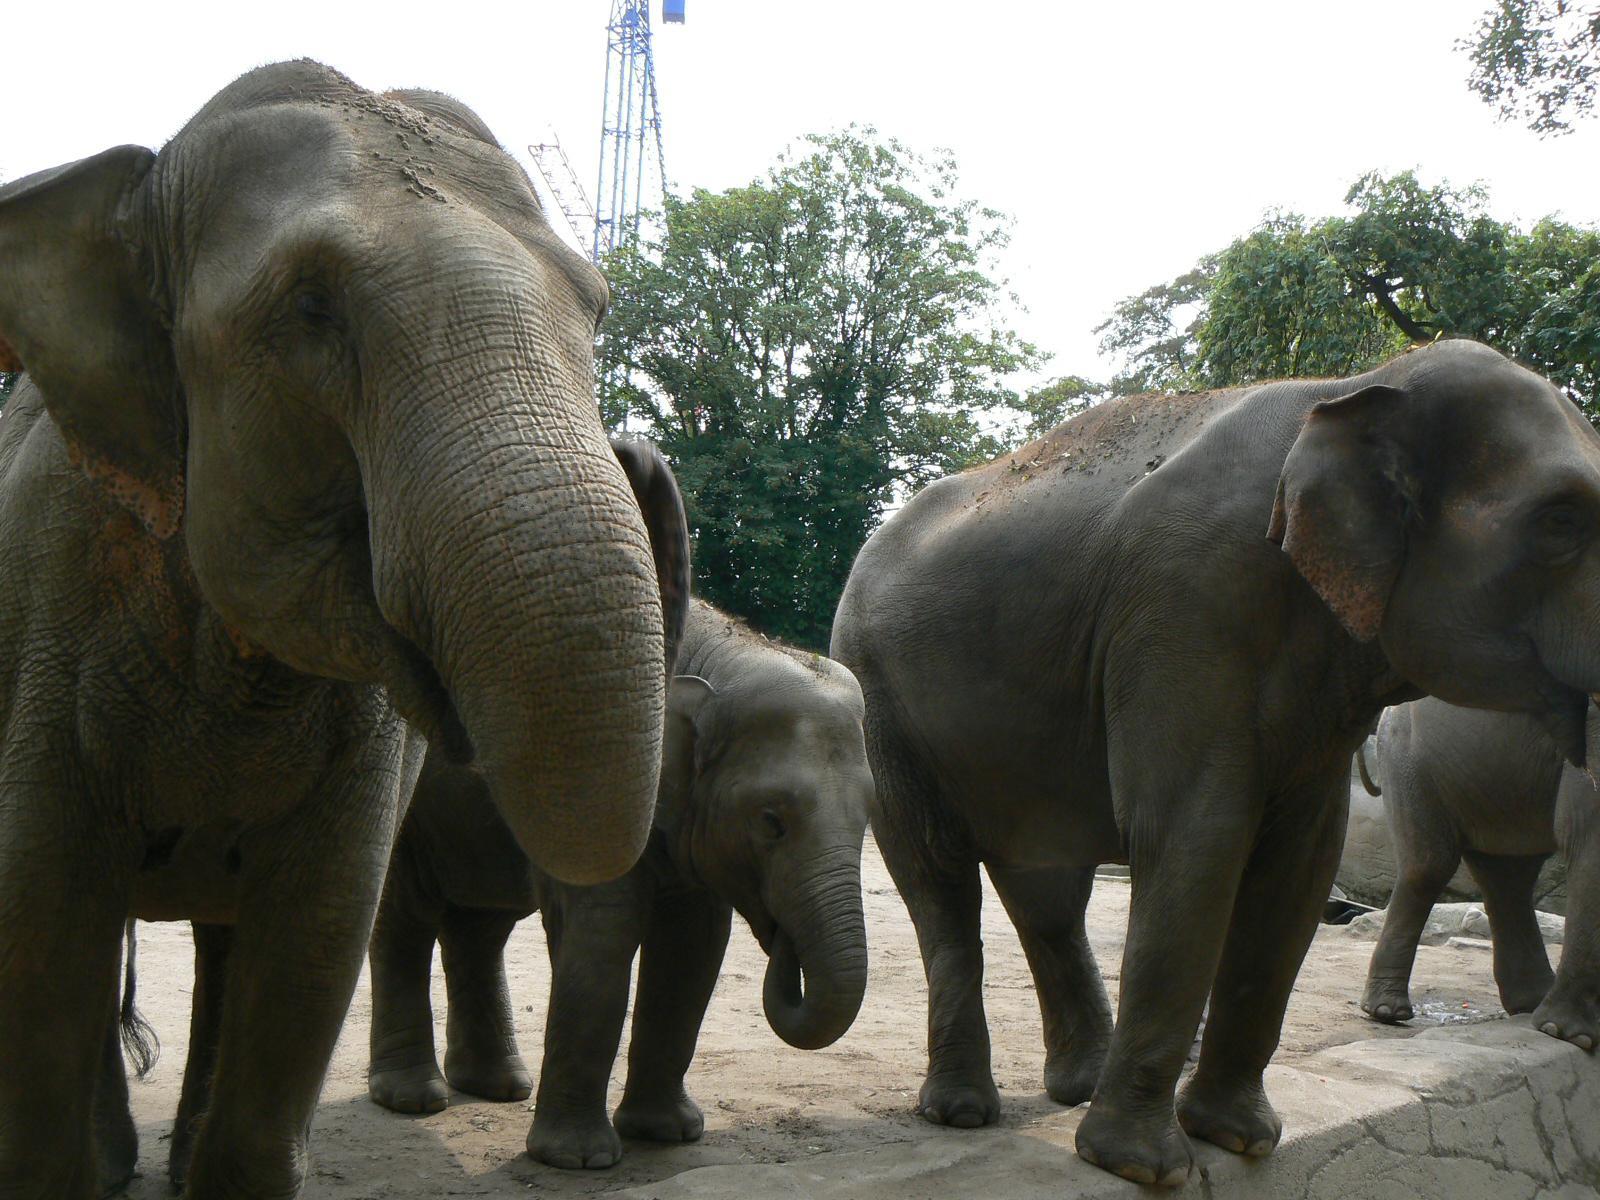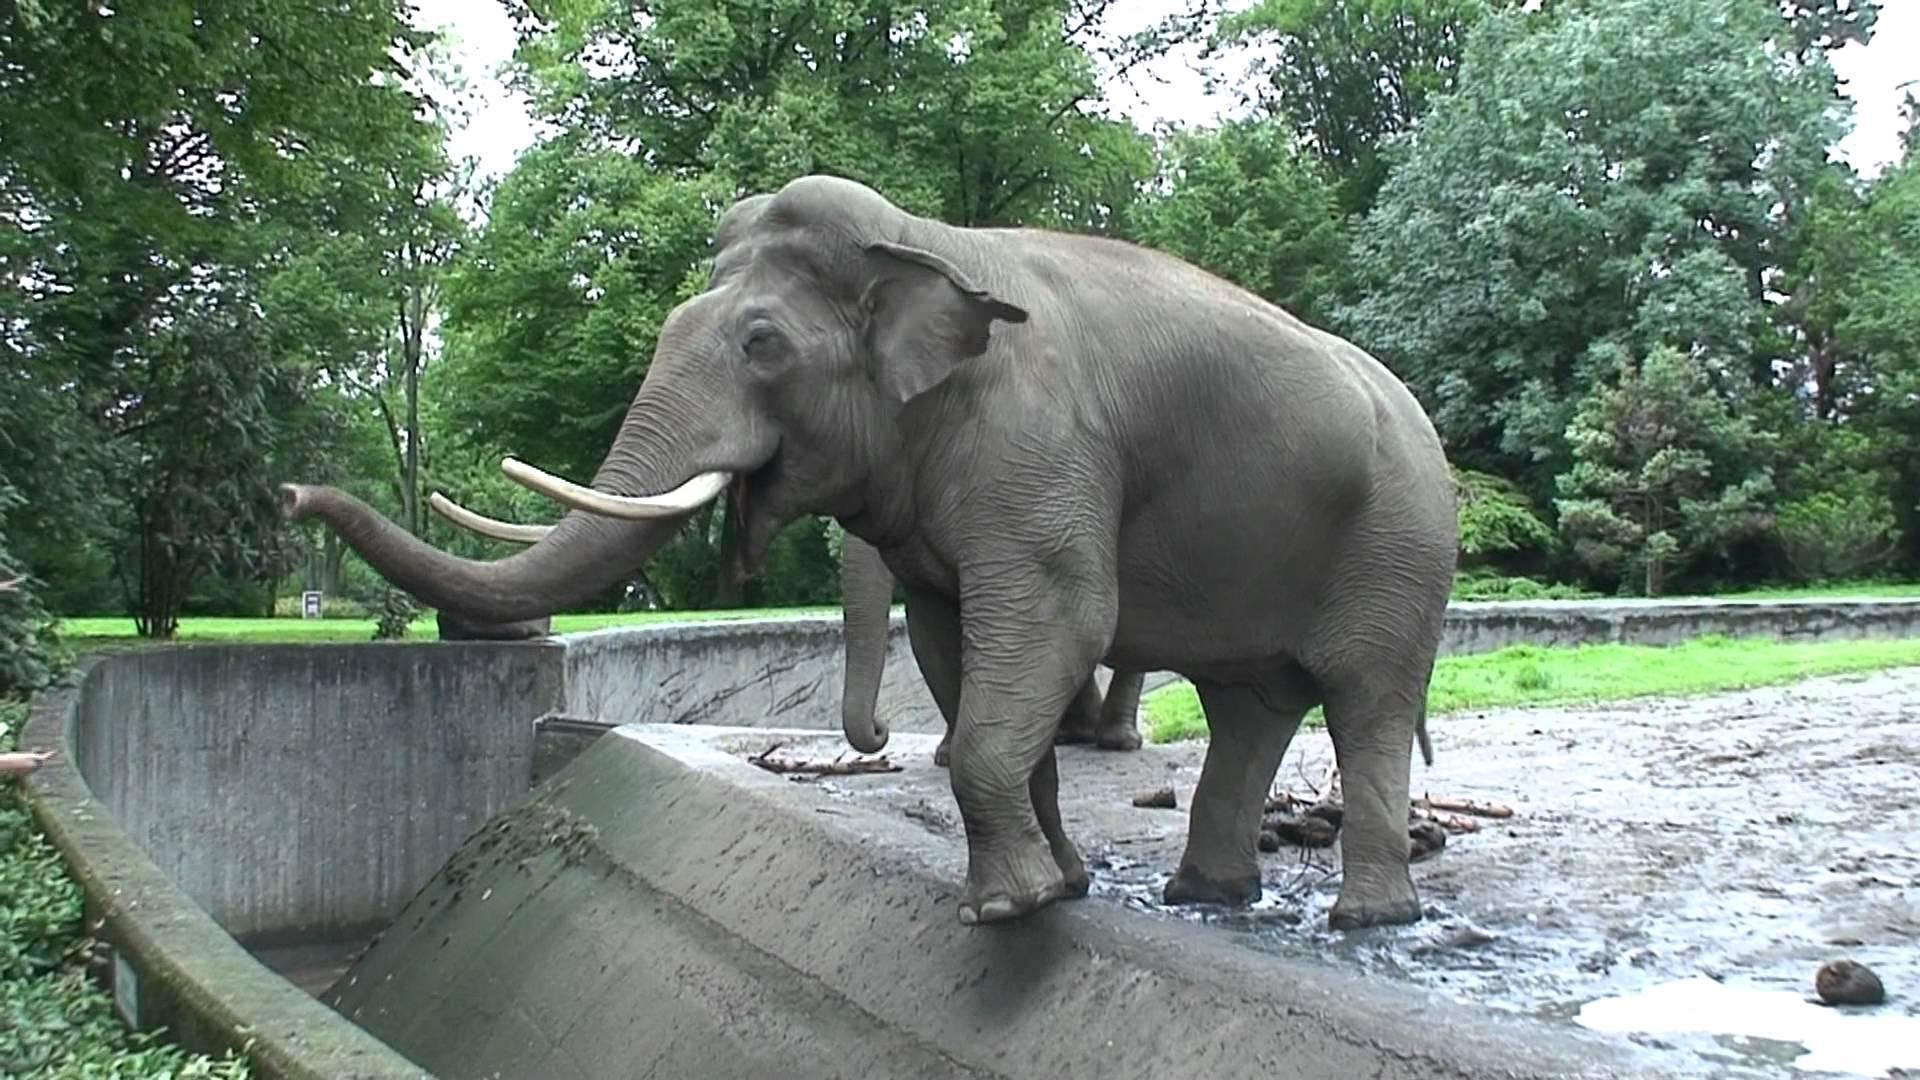The first image is the image on the left, the second image is the image on the right. Assess this claim about the two images: "There are the same number of elephants in both images.". Correct or not? Answer yes or no. No. The first image is the image on the left, the second image is the image on the right. For the images shown, is this caption "There's at least three elephants." true? Answer yes or no. Yes. 